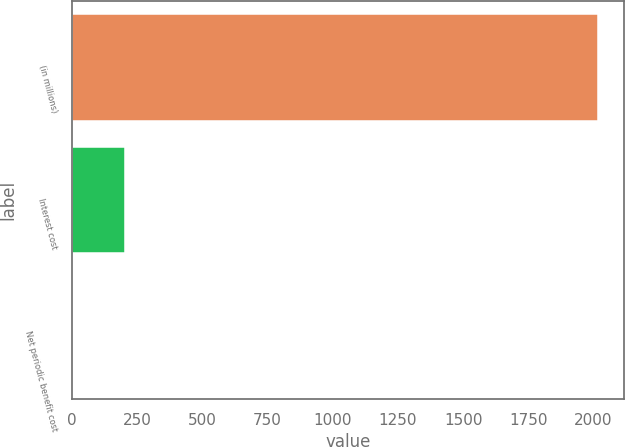Convert chart to OTSL. <chart><loc_0><loc_0><loc_500><loc_500><bar_chart><fcel>(in millions)<fcel>Interest cost<fcel>Net periodic benefit cost<nl><fcel>2016<fcel>205.2<fcel>4<nl></chart> 